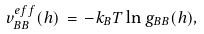<formula> <loc_0><loc_0><loc_500><loc_500>v _ { B B } ^ { e f f } ( h ) \, = \, - k _ { B } T \ln g _ { B B } ( h ) ,</formula> 